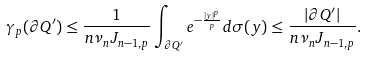<formula> <loc_0><loc_0><loc_500><loc_500>\gamma _ { p } ( \partial Q ^ { \prime } ) \leq \frac { 1 } { n \nu _ { n } J _ { n - 1 , p } } \int _ { \partial Q ^ { \prime } } e ^ { - \frac { | y | ^ { p } } { p } } d \sigma ( y ) \leq \frac { | \partial Q ^ { \prime } | } { n \nu _ { n } J _ { n - 1 , p } } .</formula> 